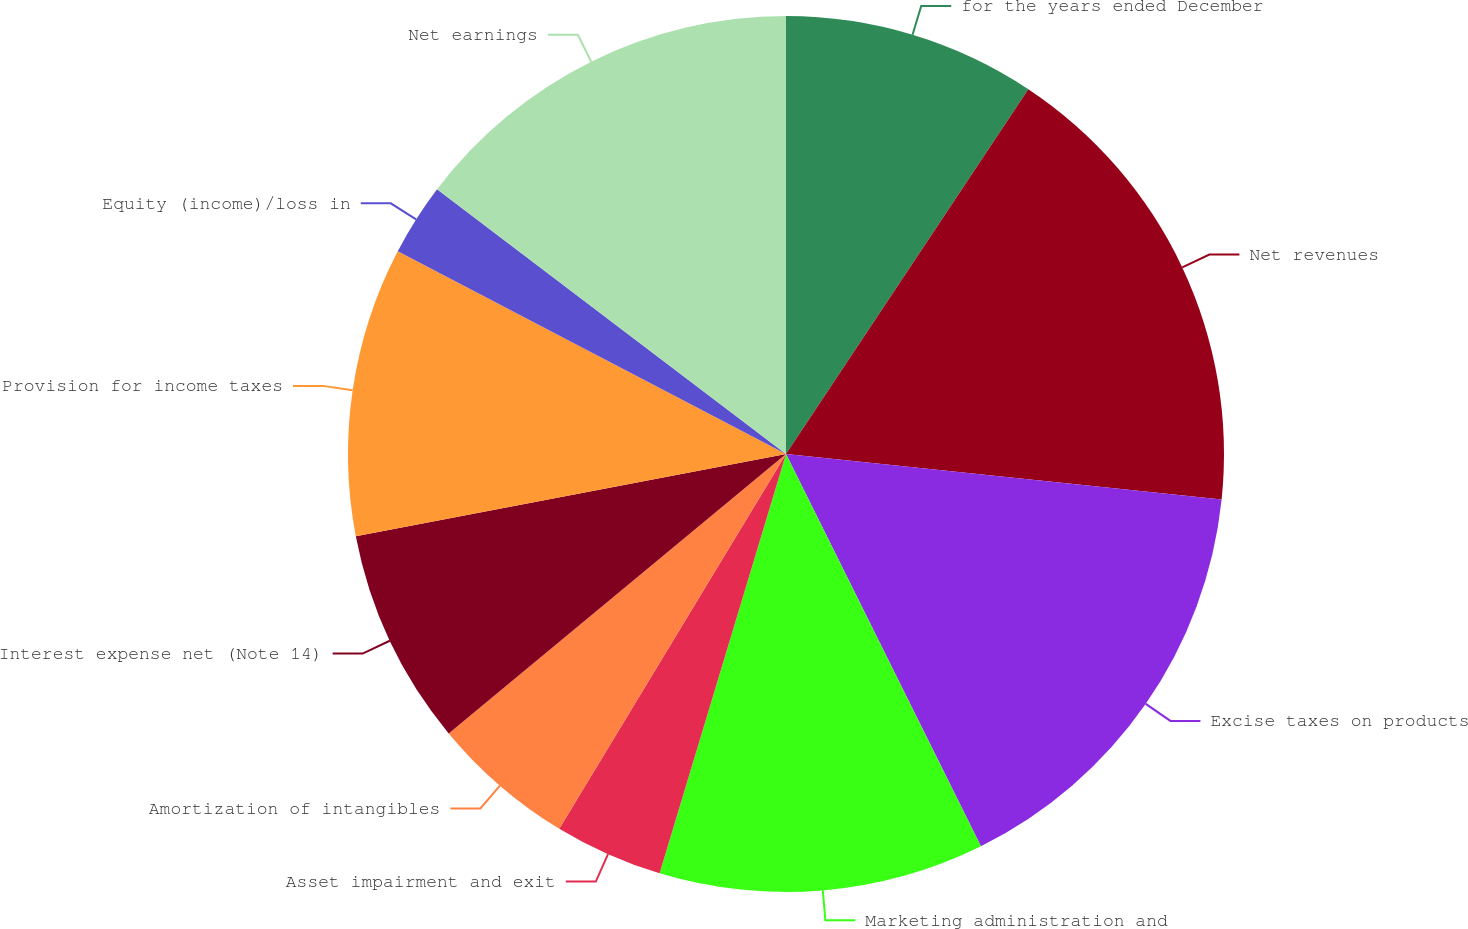Convert chart. <chart><loc_0><loc_0><loc_500><loc_500><pie_chart><fcel>for the years ended December<fcel>Net revenues<fcel>Excise taxes on products<fcel>Marketing administration and<fcel>Asset impairment and exit<fcel>Amortization of intangibles<fcel>Interest expense net (Note 14)<fcel>Provision for income taxes<fcel>Equity (income)/loss in<fcel>Net earnings<nl><fcel>9.33%<fcel>17.33%<fcel>16.0%<fcel>12.0%<fcel>4.0%<fcel>5.33%<fcel>8.0%<fcel>10.67%<fcel>2.67%<fcel>14.67%<nl></chart> 